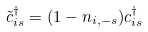<formula> <loc_0><loc_0><loc_500><loc_500>\tilde { c } ^ { \dagger } _ { i s } = ( 1 - n _ { i , - s } ) c ^ { \dagger } _ { i s }</formula> 